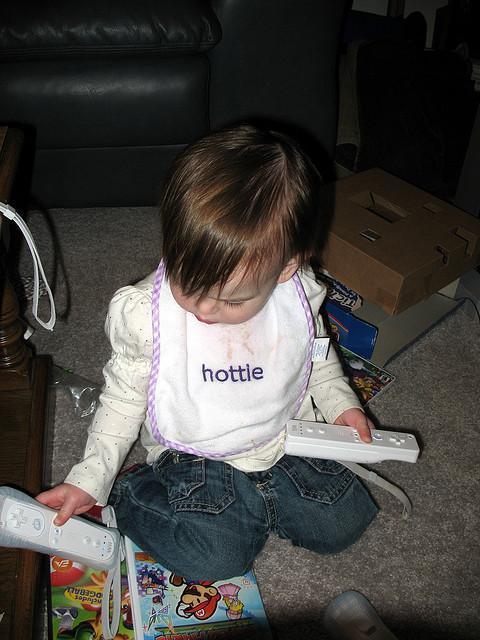How many remotes can you see?
Give a very brief answer. 2. How many books are there?
Give a very brief answer. 2. How many oranges are in the bowl?
Give a very brief answer. 0. 